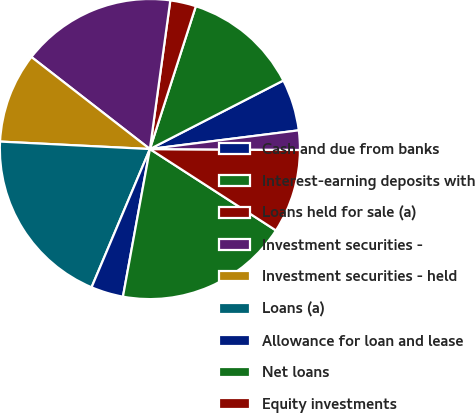Convert chart to OTSL. <chart><loc_0><loc_0><loc_500><loc_500><pie_chart><fcel>Cash and due from banks<fcel>Interest-earning deposits with<fcel>Loans held for sale (a)<fcel>Investment securities -<fcel>Investment securities - held<fcel>Loans (a)<fcel>Allowance for loan and lease<fcel>Net loans<fcel>Equity investments<fcel>Mortgage servicing rights<nl><fcel>5.56%<fcel>12.5%<fcel>2.78%<fcel>16.66%<fcel>9.72%<fcel>19.44%<fcel>3.48%<fcel>18.75%<fcel>9.03%<fcel>2.09%<nl></chart> 